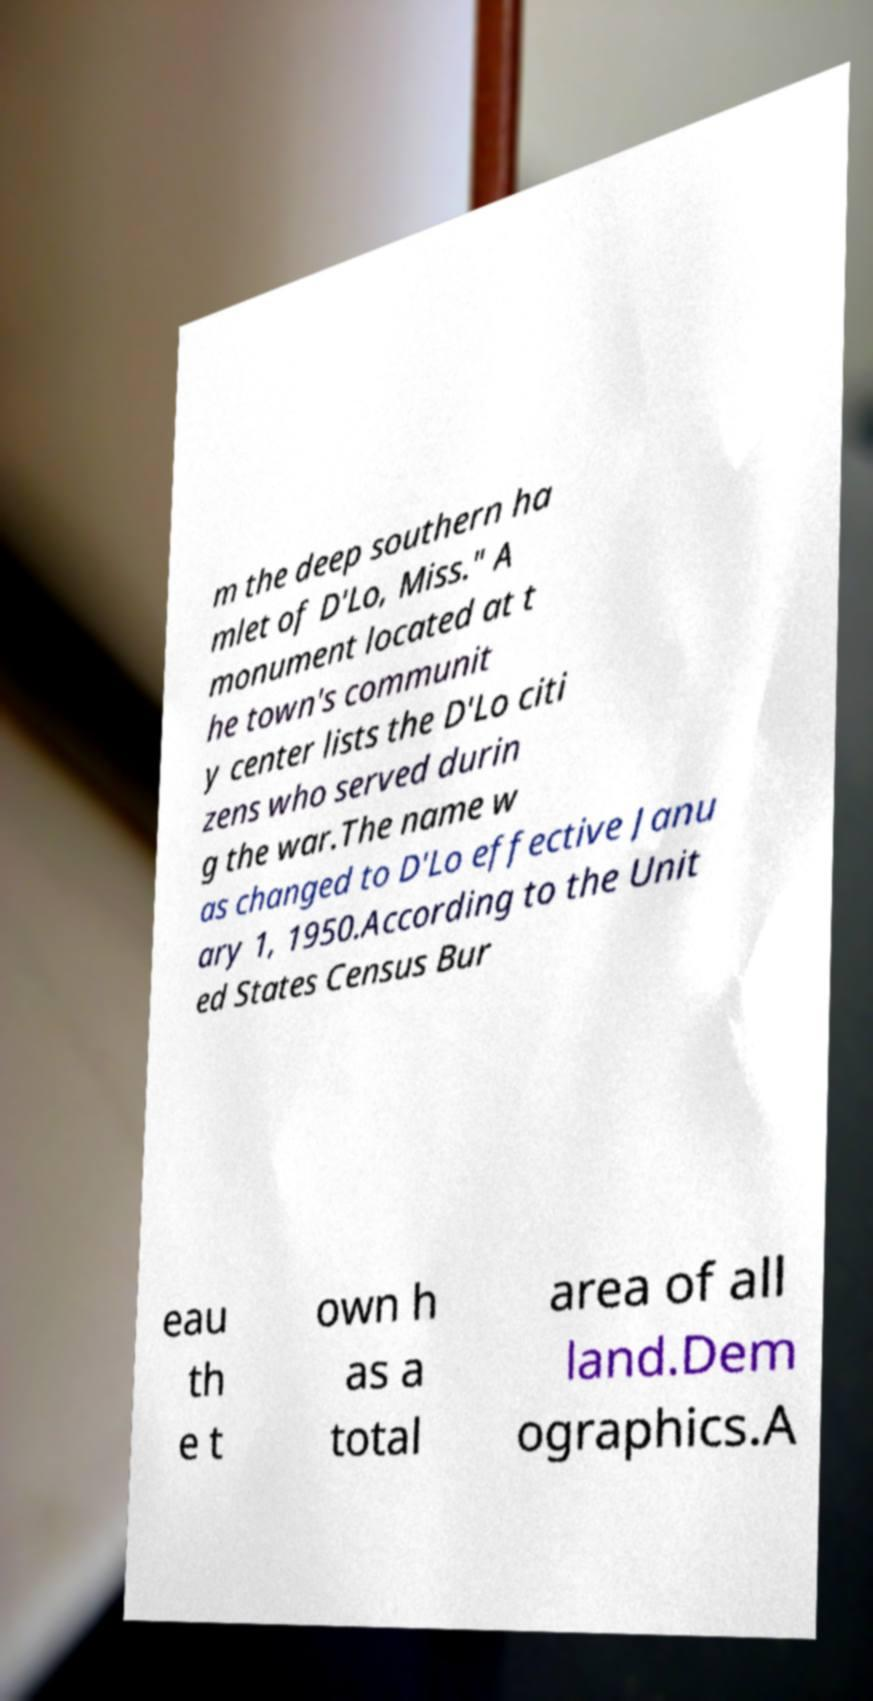Could you assist in decoding the text presented in this image and type it out clearly? m the deep southern ha mlet of D'Lo, Miss." A monument located at t he town's communit y center lists the D'Lo citi zens who served durin g the war.The name w as changed to D'Lo effective Janu ary 1, 1950.According to the Unit ed States Census Bur eau th e t own h as a total area of all land.Dem ographics.A 